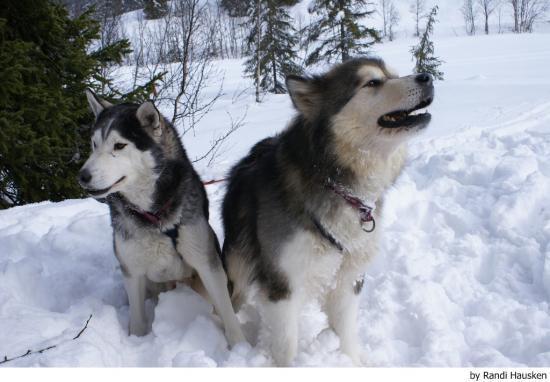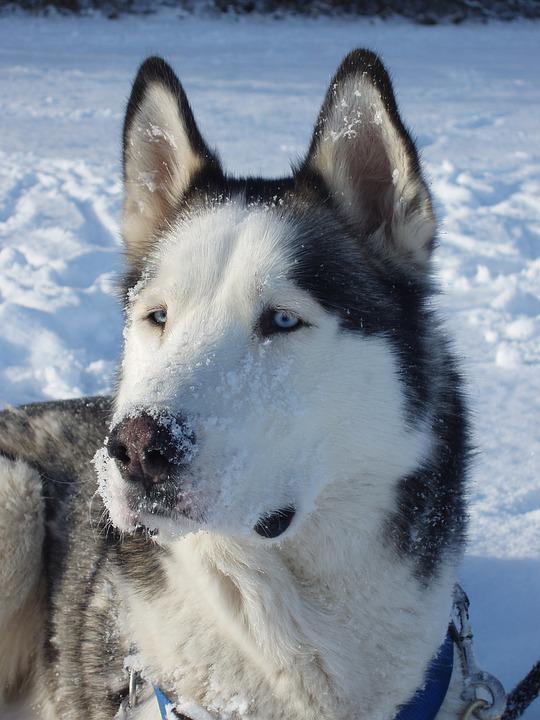The first image is the image on the left, the second image is the image on the right. Assess this claim about the two images: "The right image contains one dog, who is looking at the camera with a smiling face and his tongue hanging down past his chin.". Correct or not? Answer yes or no. No. The first image is the image on the left, the second image is the image on the right. For the images displayed, is the sentence "The left and right image contains a total of three dogs with at least two in the snow." factually correct? Answer yes or no. Yes. 